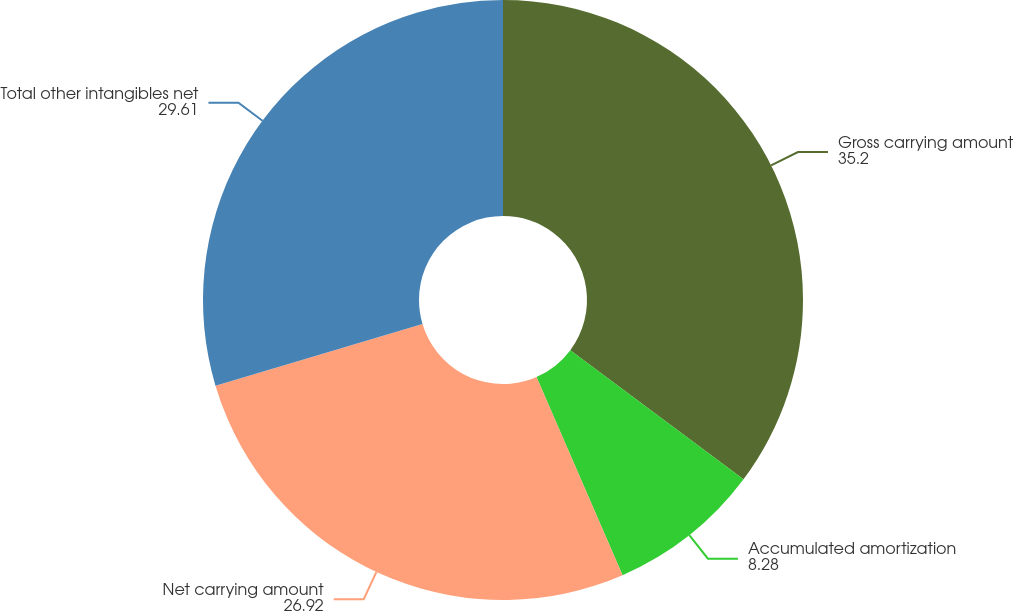Convert chart to OTSL. <chart><loc_0><loc_0><loc_500><loc_500><pie_chart><fcel>Gross carrying amount<fcel>Accumulated amortization<fcel>Net carrying amount<fcel>Total other intangibles net<nl><fcel>35.2%<fcel>8.28%<fcel>26.92%<fcel>29.61%<nl></chart> 